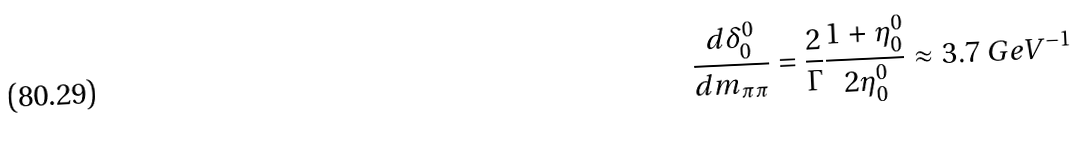Convert formula to latex. <formula><loc_0><loc_0><loc_500><loc_500>\frac { d \delta _ { 0 } ^ { 0 } } { d m _ { \pi \pi } } = \frac { 2 } { \Gamma } \frac { 1 + \eta ^ { 0 } _ { 0 } } { 2 \eta ^ { 0 } _ { 0 } } \approx 3 . 7 \ G e V ^ { - 1 }</formula> 